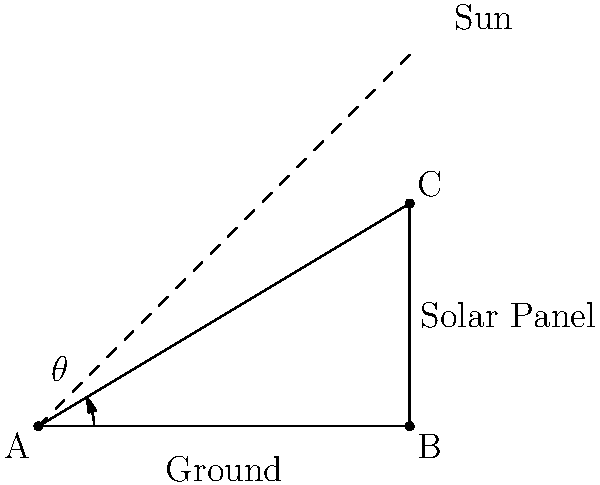As an environmental science student, you're assisting in the installation of solar panels on campus. The optimal angle of elevation for the panels is equal to the latitude of your location, which is 31°. Given a flat roof structure, calculate the length of the support (AC) needed to achieve this optimal angle if the base of the support (AB) is 100 cm long. Let's approach this step-by-step:

1) We have a right-angled triangle ABC, where:
   - AB is the base (ground)
   - BC is the height of the support
   - AC is the length of the support we need to find
   - Angle BAC is the optimal angle, 31°

2) We know that:
   - AB = 100 cm
   - Angle BAC = 31°

3) To find AC, we can use the cosine function:

   $\cos(\theta) = \frac{\text{adjacent}}{\text{hypotenuse}}$

   $\cos(31°) = \frac{AB}{AC}$

4) Rearranging this equation:

   $AC = \frac{AB}{\cos(31°)}$

5) Now we can plug in our known values:

   $AC = \frac{100}{\cos(31°)}$

6) Using a calculator (or computer):

   $AC \approx 116.19$ cm

Therefore, the support (AC) needs to be approximately 116.19 cm long to achieve the optimal angle of 31°.
Answer: 116.19 cm 